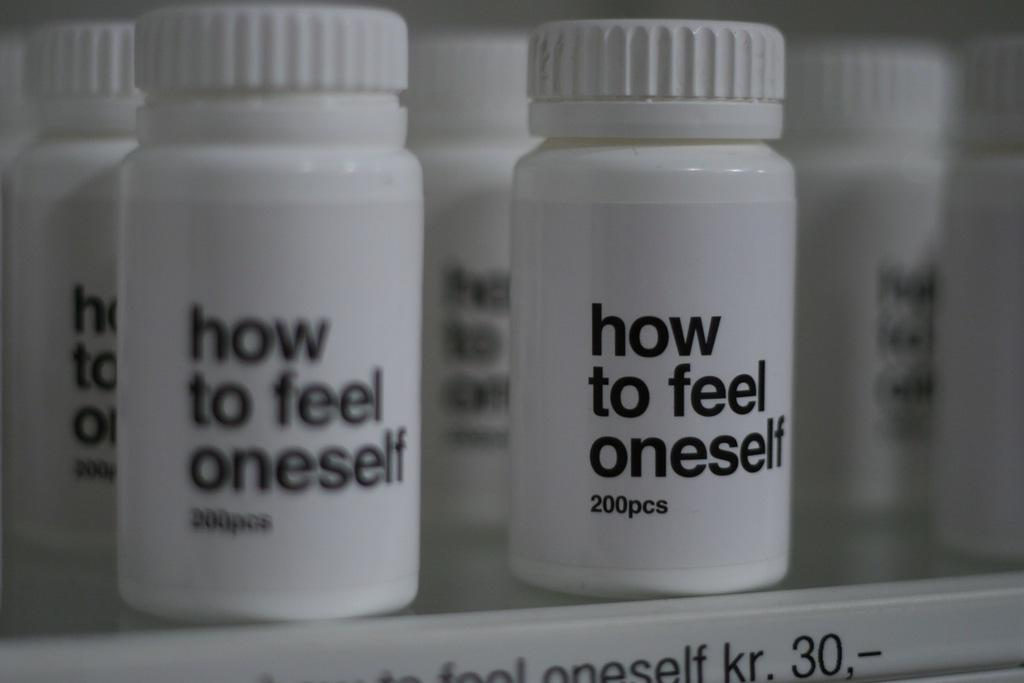<image>
Write a terse but informative summary of the picture. bottles on top of a shelf that are labeled 'how to feel oneself 200pcs' 